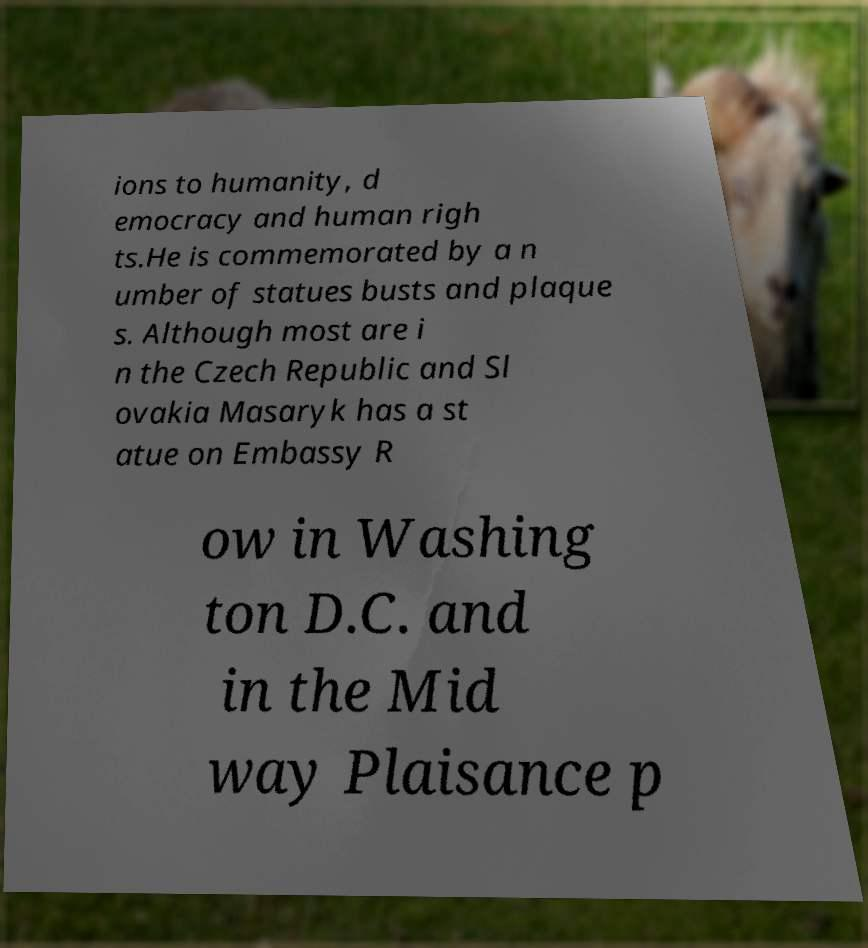Can you read and provide the text displayed in the image?This photo seems to have some interesting text. Can you extract and type it out for me? ions to humanity, d emocracy and human righ ts.He is commemorated by a n umber of statues busts and plaque s. Although most are i n the Czech Republic and Sl ovakia Masaryk has a st atue on Embassy R ow in Washing ton D.C. and in the Mid way Plaisance p 